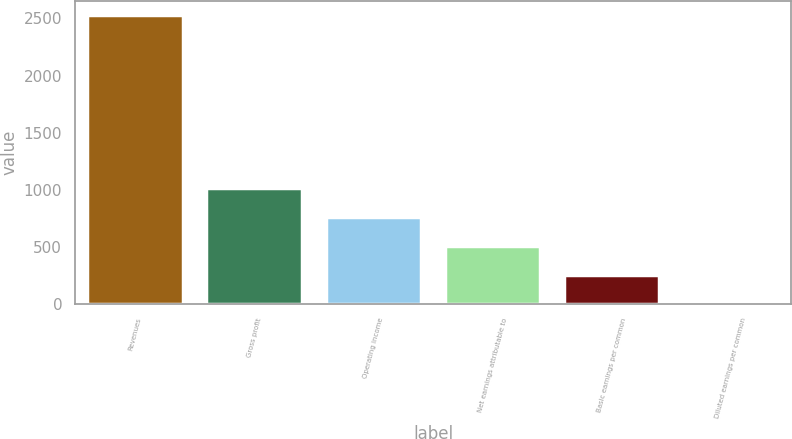Convert chart. <chart><loc_0><loc_0><loc_500><loc_500><bar_chart><fcel>Revenues<fcel>Gross profit<fcel>Operating income<fcel>Net earnings attributable to<fcel>Basic earnings per common<fcel>Diluted earnings per common<nl><fcel>2528.2<fcel>1012.34<fcel>759.7<fcel>507.06<fcel>254.42<fcel>1.78<nl></chart> 